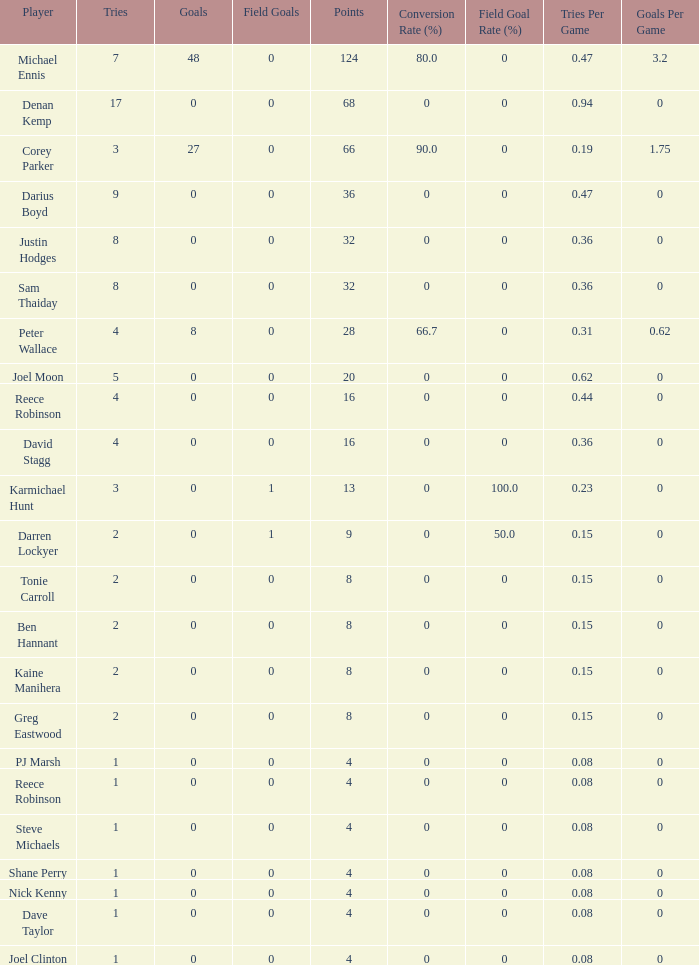How many points did the player with 2 tries and more than 0 field goals have? 9.0. 